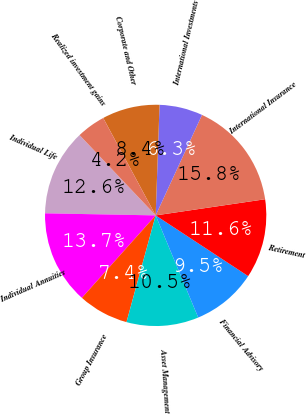Convert chart. <chart><loc_0><loc_0><loc_500><loc_500><pie_chart><fcel>Individual Life<fcel>Individual Annuities<fcel>Group Insurance<fcel>Asset Management<fcel>Financial Advisory<fcel>Retirement<fcel>International Insurance<fcel>International Investments<fcel>Corporate and Other<fcel>Realized investment gains<nl><fcel>12.63%<fcel>13.68%<fcel>7.37%<fcel>10.53%<fcel>9.47%<fcel>11.58%<fcel>15.79%<fcel>6.32%<fcel>8.42%<fcel>4.21%<nl></chart> 